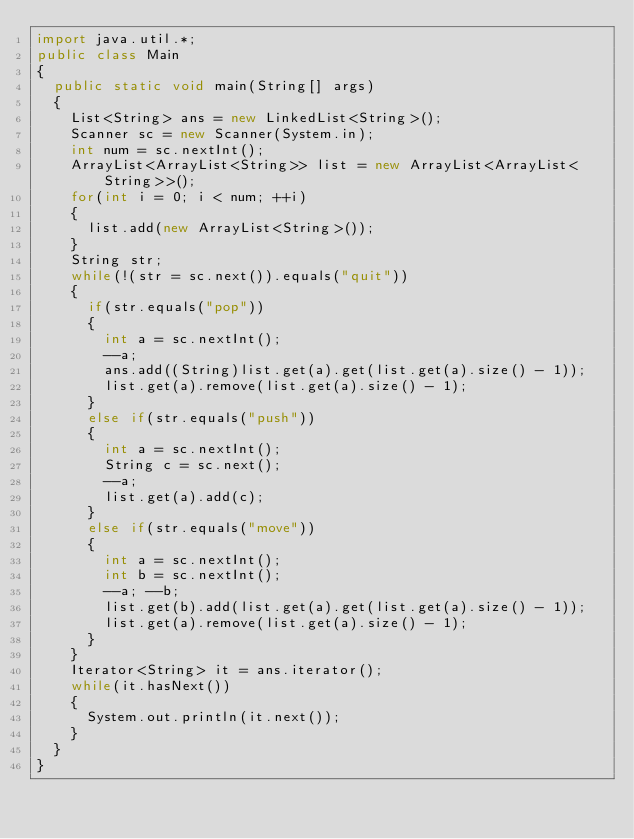<code> <loc_0><loc_0><loc_500><loc_500><_Java_>import java.util.*;
public class Main 
{
	public static void main(String[] args) 
	{
		List<String> ans = new LinkedList<String>();
		Scanner sc = new Scanner(System.in);
		int num = sc.nextInt();
		ArrayList<ArrayList<String>> list = new ArrayList<ArrayList<String>>();
		for(int i = 0; i < num; ++i)
		{
			list.add(new ArrayList<String>());
		}
		String str;
		while(!(str = sc.next()).equals("quit"))
		{
			if(str.equals("pop"))
			{
				int a = sc.nextInt();
				--a;
				ans.add((String)list.get(a).get(list.get(a).size() - 1));
				list.get(a).remove(list.get(a).size() - 1);
			}
			else if(str.equals("push"))
			{
				int a = sc.nextInt();
				String c = sc.next();
				--a;
				list.get(a).add(c);
			}
			else if(str.equals("move"))
			{
				int a = sc.nextInt();
				int b = sc.nextInt();
				--a; --b;
				list.get(b).add(list.get(a).get(list.get(a).size() - 1));
				list.get(a).remove(list.get(a).size() - 1);
			}
		}
		Iterator<String> it = ans.iterator();
		while(it.hasNext())
		{
			System.out.println(it.next());
		}
	}
}</code> 